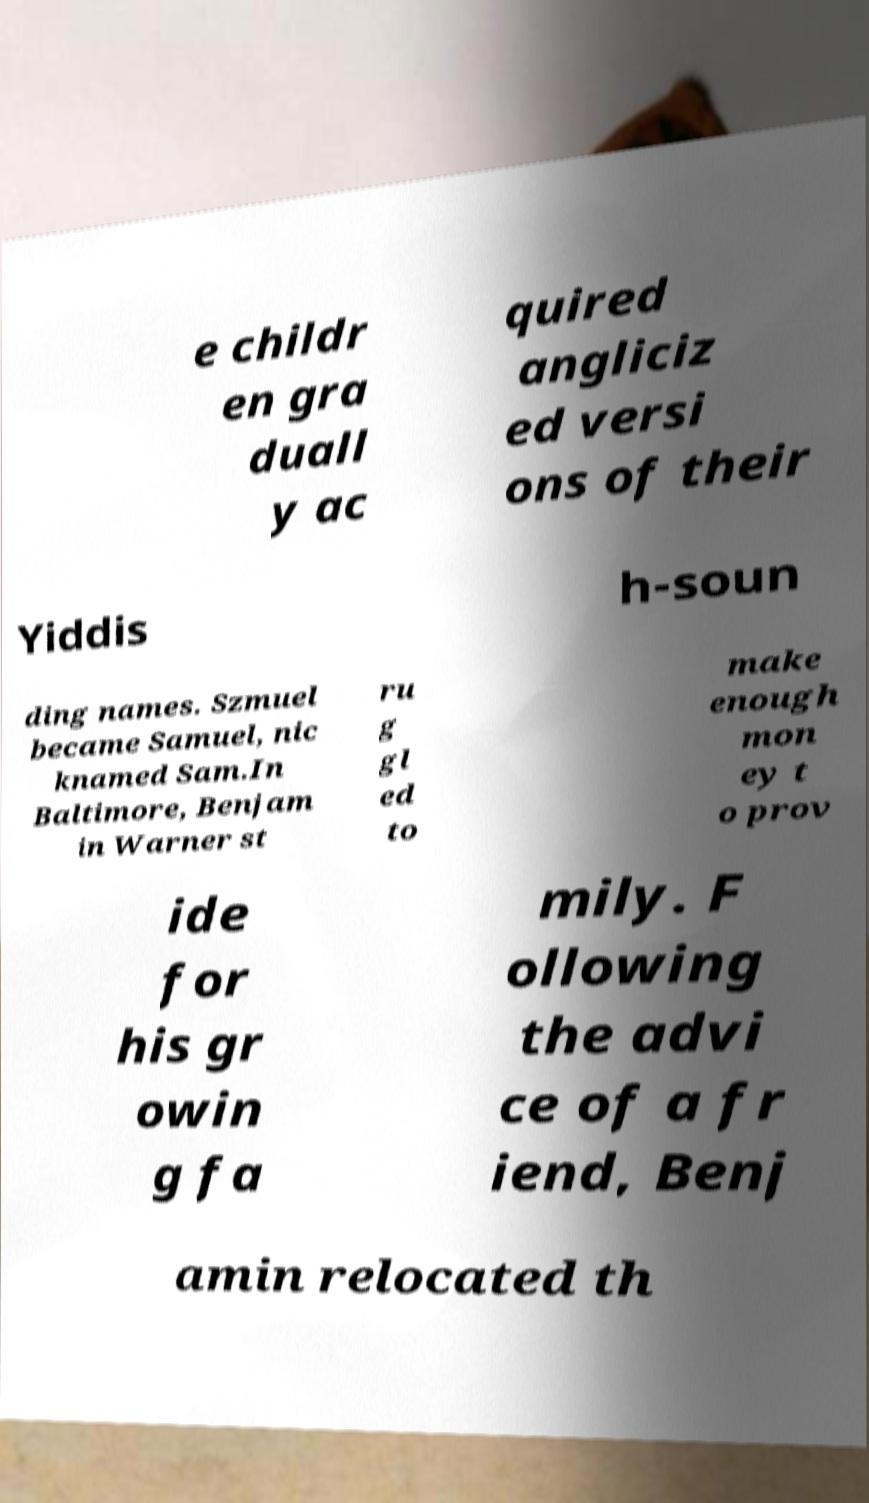Can you read and provide the text displayed in the image?This photo seems to have some interesting text. Can you extract and type it out for me? e childr en gra duall y ac quired angliciz ed versi ons of their Yiddis h-soun ding names. Szmuel became Samuel, nic knamed Sam.In Baltimore, Benjam in Warner st ru g gl ed to make enough mon ey t o prov ide for his gr owin g fa mily. F ollowing the advi ce of a fr iend, Benj amin relocated th 